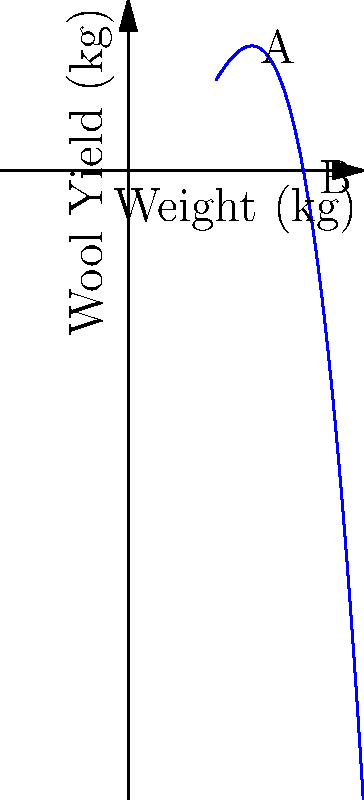The graph shows the relationship between sheep weight and wool yield. At what weight does the wool yield reach its maximum? What is the approximate maximum wool yield? To find the maximum wool yield and the corresponding sheep weight, we need to analyze the polynomial graph:

1. The graph is a cubic function, with a clear maximum point.

2. To find the maximum point, we need to identify where the slope of the curve is zero (i.e., the derivative equals zero).

3. Visually, this occurs at the peak of the curve, which is between points A and B.

4. Estimating from the graph:
   - The maximum point appears to be around 50 kg on the x-axis (weight).
   - The corresponding y-value (wool yield) at this point is approximately 6 kg.

5. To be more precise:
   - The x-coordinate of the maximum point is the average of the x-coordinates of points A and B: $(40 + 60) / 2 = 50$ kg.
   - The y-coordinate can be estimated by looking at the y-axis value corresponding to the peak.

Therefore, the wool yield reaches its maximum when the sheep weight is about 50 kg, and the maximum wool yield is approximately 6 kg.
Answer: 50 kg; 6 kg 